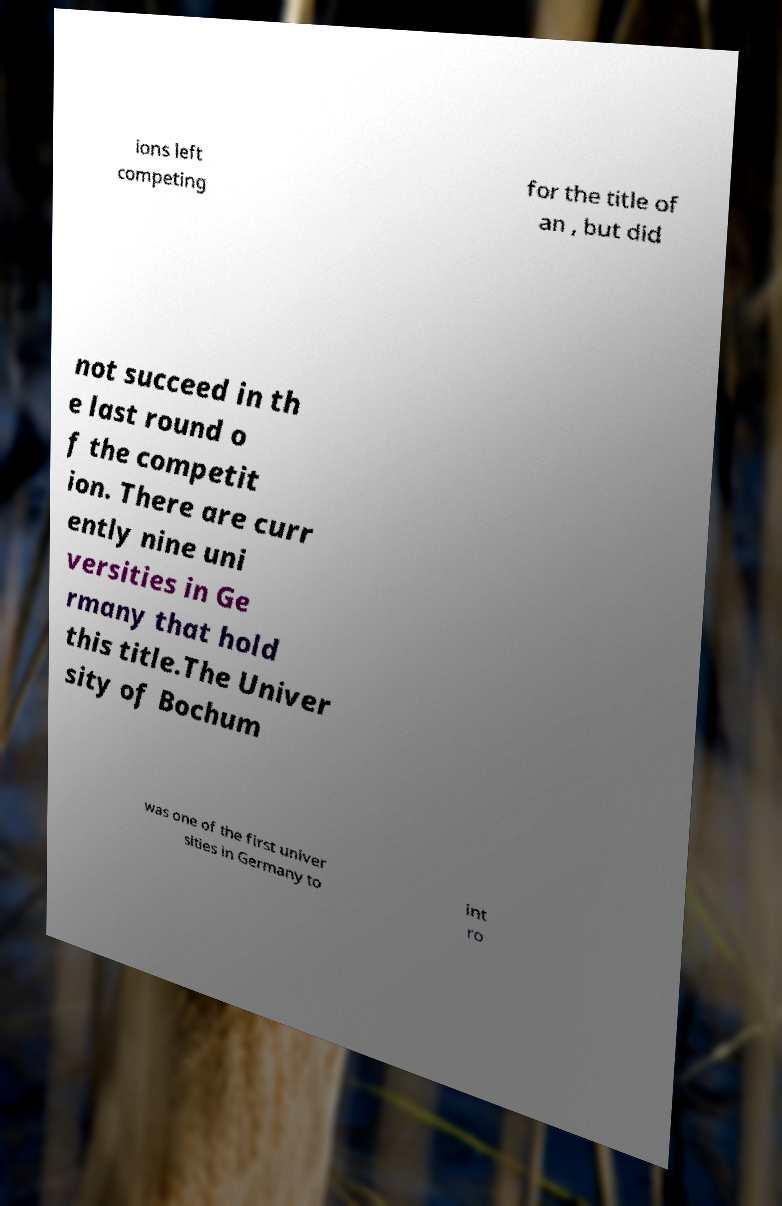There's text embedded in this image that I need extracted. Can you transcribe it verbatim? ions left competing for the title of an , but did not succeed in th e last round o f the competit ion. There are curr ently nine uni versities in Ge rmany that hold this title.The Univer sity of Bochum was one of the first univer sities in Germany to int ro 